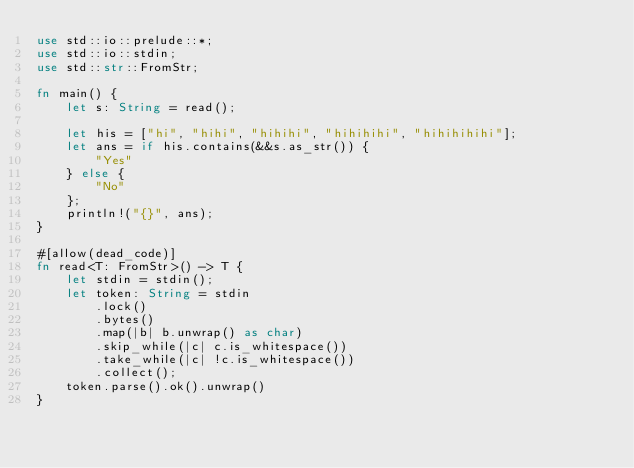<code> <loc_0><loc_0><loc_500><loc_500><_Rust_>use std::io::prelude::*;
use std::io::stdin;
use std::str::FromStr;

fn main() {
    let s: String = read();

    let his = ["hi", "hihi", "hihihi", "hihihihi", "hihihihihi"];
    let ans = if his.contains(&&s.as_str()) {
        "Yes"
    } else {
        "No"
    };
    println!("{}", ans);
}

#[allow(dead_code)]
fn read<T: FromStr>() -> T {
    let stdin = stdin();
    let token: String = stdin
        .lock()
        .bytes()
        .map(|b| b.unwrap() as char)
        .skip_while(|c| c.is_whitespace())
        .take_while(|c| !c.is_whitespace())
        .collect();
    token.parse().ok().unwrap()
}
</code> 